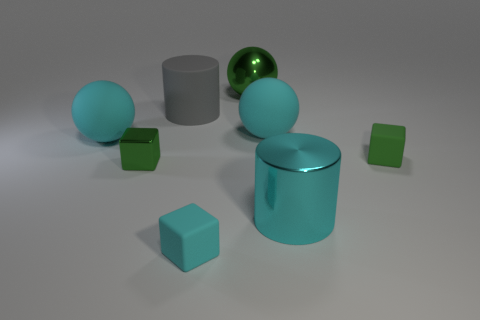What size is the matte cube that is the same color as the tiny metal object?
Offer a terse response. Small. What number of large yellow objects have the same shape as the tiny green rubber object?
Your answer should be very brief. 0. What number of spheres are either cyan objects or small things?
Ensure brevity in your answer.  2. Do the green thing that is left of the small cyan object and the tiny rubber thing on the left side of the green rubber cube have the same shape?
Give a very brief answer. Yes. What is the cyan cylinder made of?
Make the answer very short. Metal. There is a shiny thing that is the same color as the large shiny ball; what shape is it?
Offer a very short reply. Cube. What number of green metallic cubes are the same size as the cyan matte cube?
Provide a succinct answer. 1. What number of things are big gray rubber cylinders that are left of the large metal cylinder or metal objects behind the small cyan rubber block?
Your answer should be very brief. 4. Does the tiny thing that is behind the green shiny cube have the same material as the green object that is behind the matte cylinder?
Your answer should be very brief. No. What is the shape of the green thing behind the large gray matte object that is on the left side of the green rubber block?
Provide a succinct answer. Sphere. 